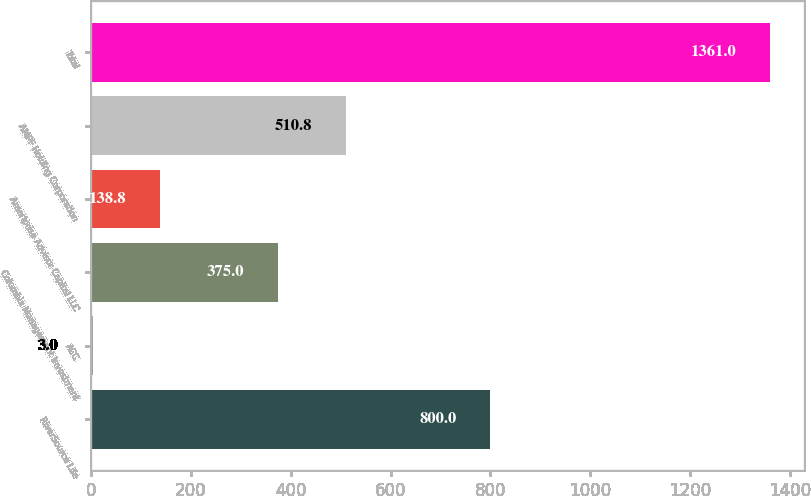Convert chart. <chart><loc_0><loc_0><loc_500><loc_500><bar_chart><fcel>RiverSource Life<fcel>ACC<fcel>Columbia Management Investment<fcel>Ameriprise Advisor Capital LLC<fcel>AMPF Holding Corporation<fcel>Total<nl><fcel>800<fcel>3<fcel>375<fcel>138.8<fcel>510.8<fcel>1361<nl></chart> 